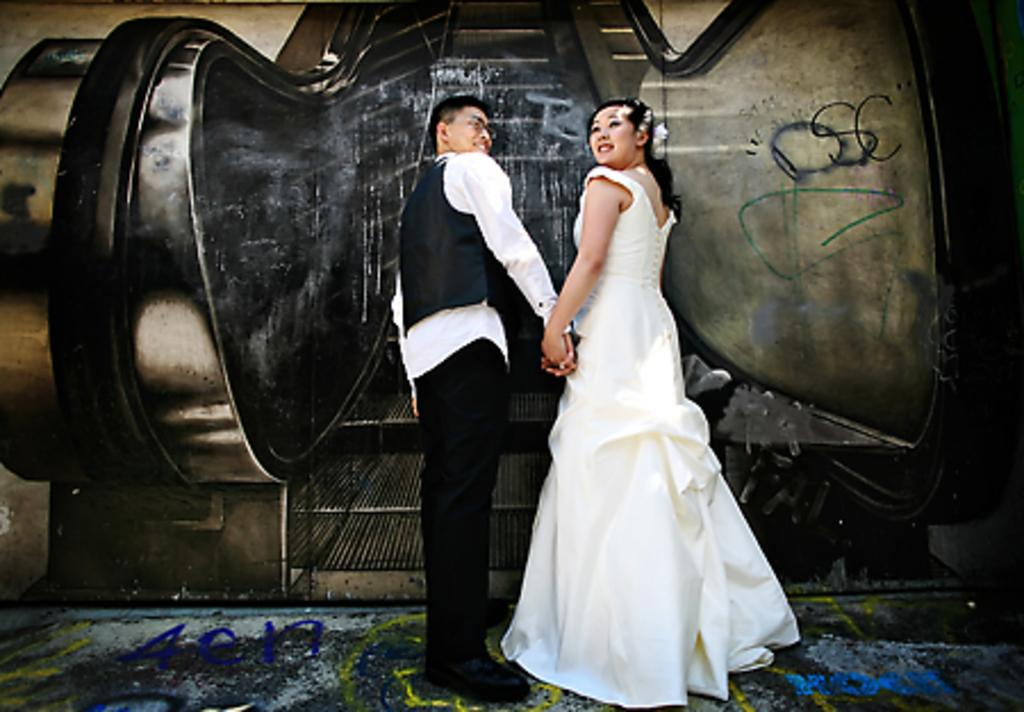Who can be seen in the image? There is a man and a lady in the image. What are the man and lady doing in the image? The man and lady are standing. What can be seen in the background of the image? There is an escalator in the background of the image. What type of volcano can be seen erupting in the image? There is no volcano present in the image. Can you describe the veins visible on the man's face in the image? There is no mention of the man's face or any veins in the provided facts, so we cannot answer this question. 